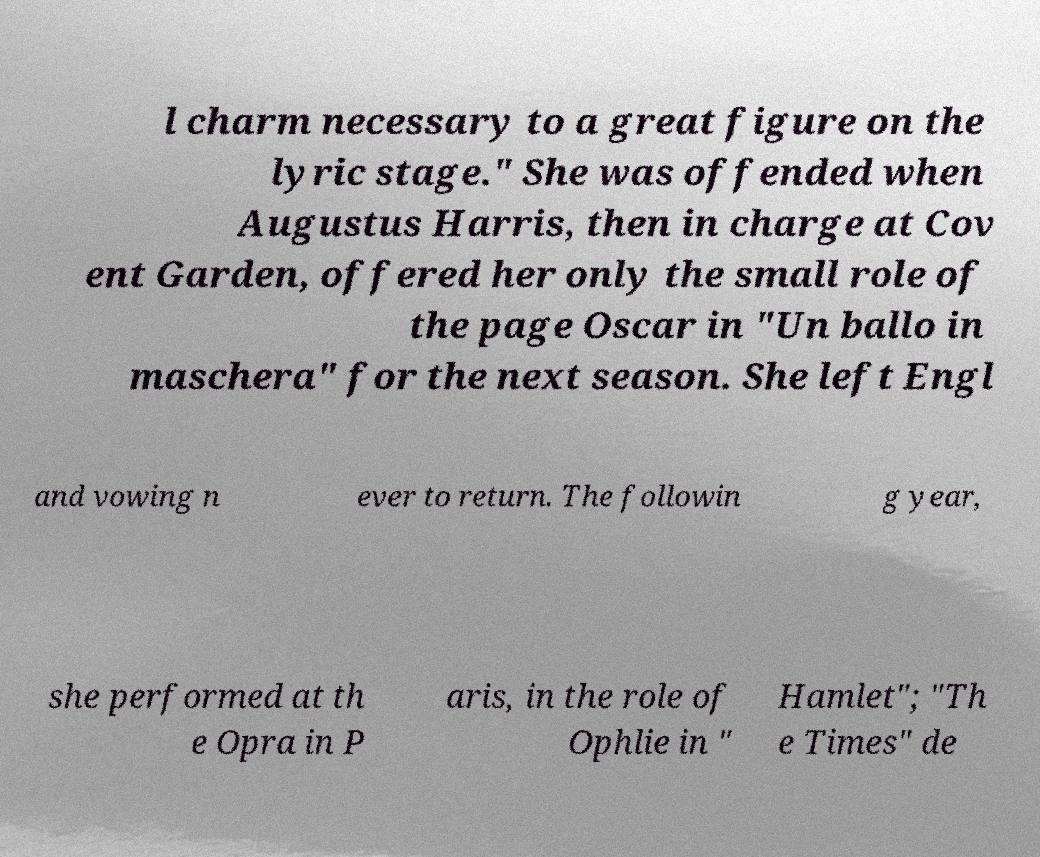There's text embedded in this image that I need extracted. Can you transcribe it verbatim? l charm necessary to a great figure on the lyric stage." She was offended when Augustus Harris, then in charge at Cov ent Garden, offered her only the small role of the page Oscar in "Un ballo in maschera" for the next season. She left Engl and vowing n ever to return. The followin g year, she performed at th e Opra in P aris, in the role of Ophlie in " Hamlet"; "Th e Times" de 